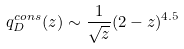Convert formula to latex. <formula><loc_0><loc_0><loc_500><loc_500>q ^ { c o n s } _ { D } ( z ) \sim \frac { 1 } { \sqrt { z } } ( 2 - z ) ^ { 4 . 5 }</formula> 